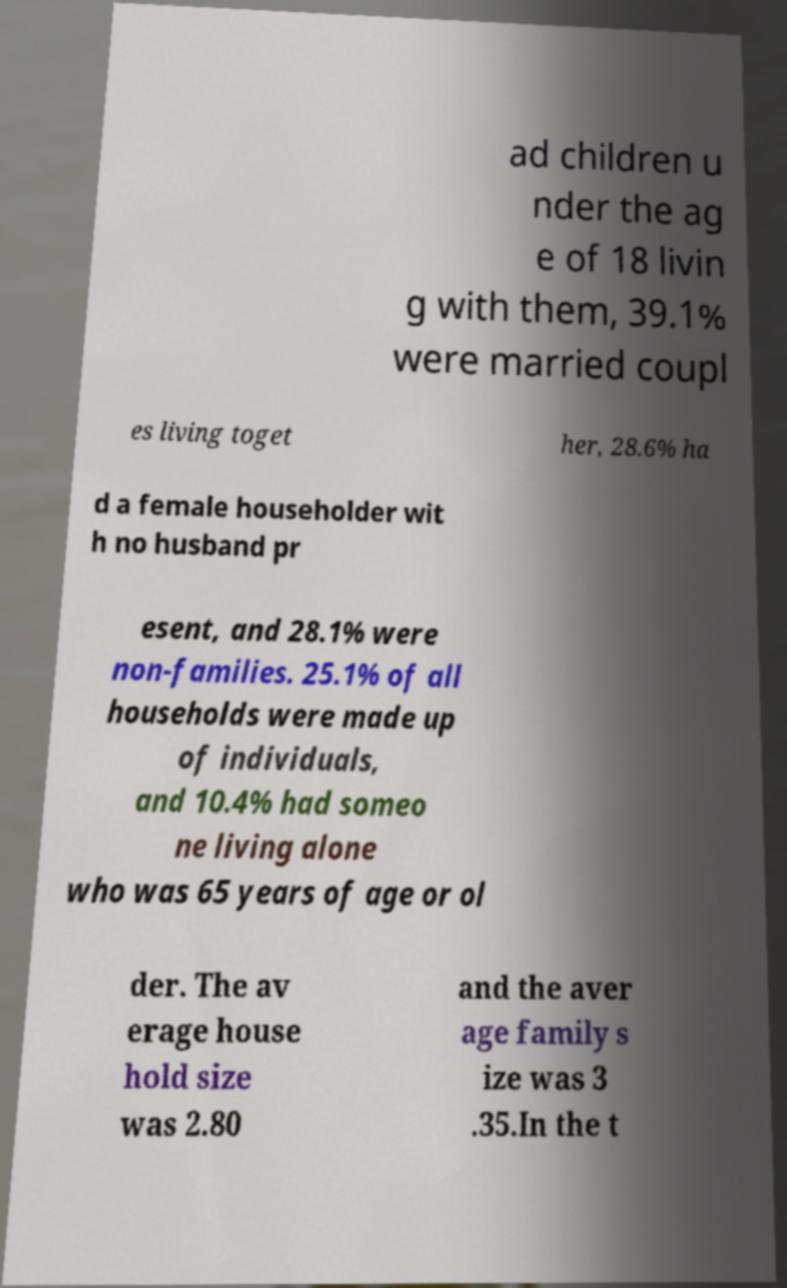I need the written content from this picture converted into text. Can you do that? ad children u nder the ag e of 18 livin g with them, 39.1% were married coupl es living toget her, 28.6% ha d a female householder wit h no husband pr esent, and 28.1% were non-families. 25.1% of all households were made up of individuals, and 10.4% had someo ne living alone who was 65 years of age or ol der. The av erage house hold size was 2.80 and the aver age family s ize was 3 .35.In the t 